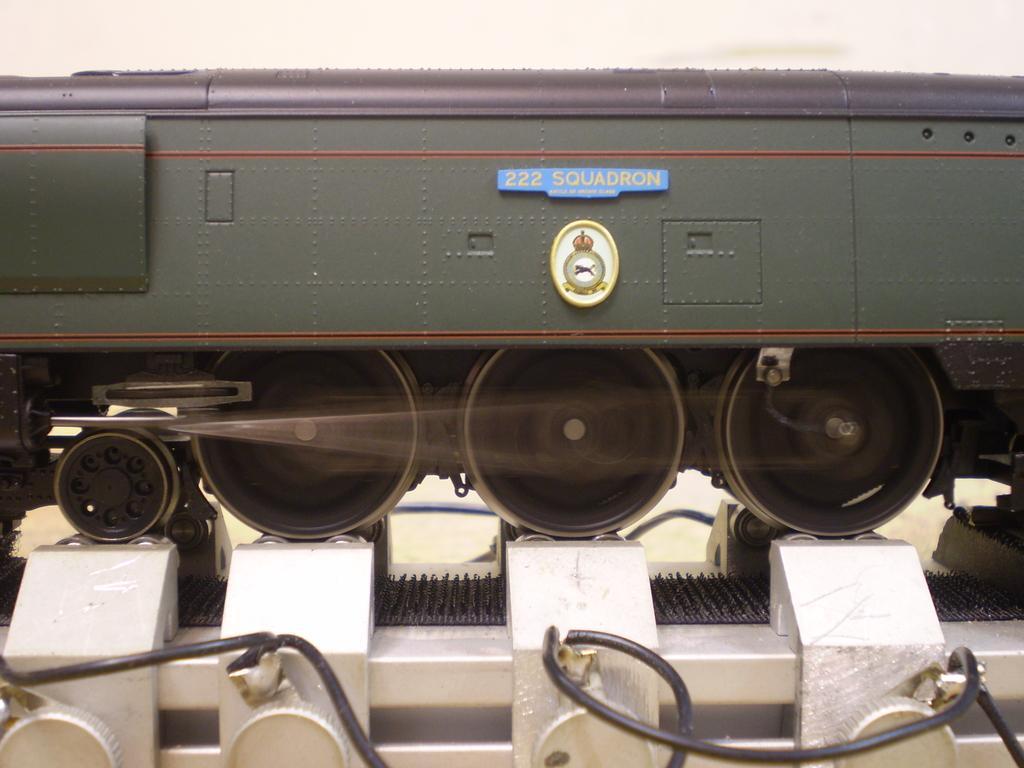Can you describe this image briefly? In this image we can see an object looks like a train. On the object we can see some text. At the bottom there is a metal. At the top we can see the wall. 